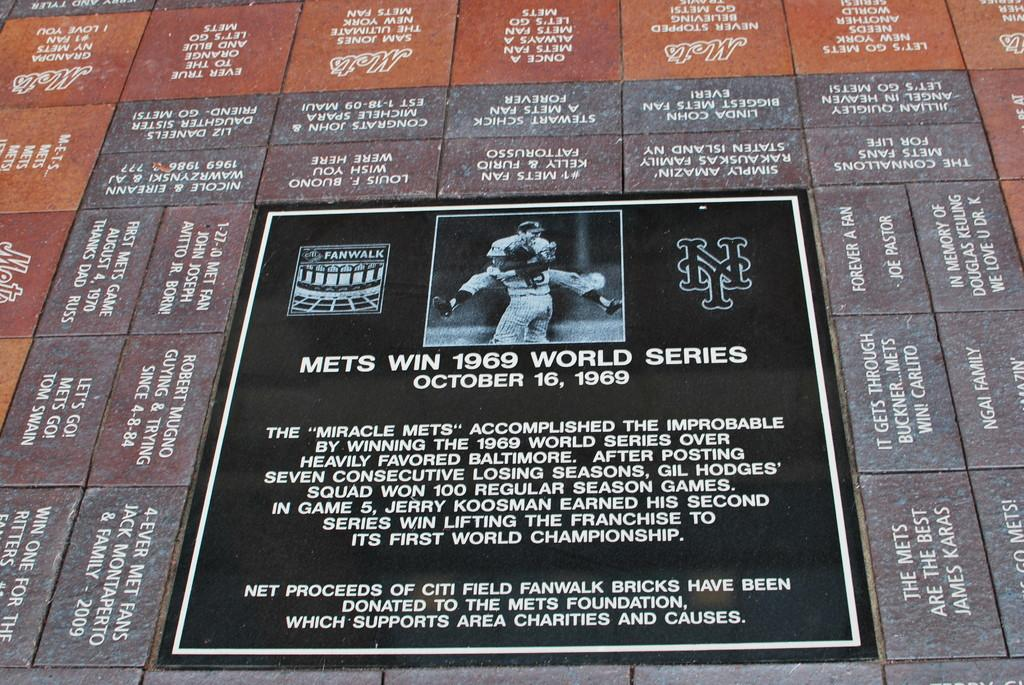<image>
Summarize the visual content of the image. Poster which says that the Mets won the world series in 1969. 